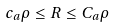Convert formula to latex. <formula><loc_0><loc_0><loc_500><loc_500>c _ { a } \rho \leq R \leq C _ { a } \rho</formula> 